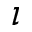<formula> <loc_0><loc_0><loc_500><loc_500>\iota</formula> 